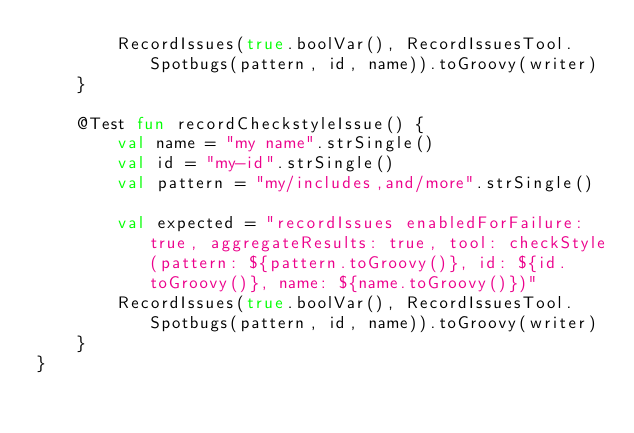Convert code to text. <code><loc_0><loc_0><loc_500><loc_500><_Kotlin_>        RecordIssues(true.boolVar(), RecordIssuesTool.Spotbugs(pattern, id, name)).toGroovy(writer)
    }

    @Test fun recordCheckstyleIssue() {
        val name = "my name".strSingle()
        val id = "my-id".strSingle()
        val pattern = "my/includes,and/more".strSingle()

        val expected = "recordIssues enabledForFailure: true, aggregateResults: true, tool: checkStyle(pattern: ${pattern.toGroovy()}, id: ${id.toGroovy()}, name: ${name.toGroovy()})"
        RecordIssues(true.boolVar(), RecordIssuesTool.Spotbugs(pattern, id, name)).toGroovy(writer)
    }
}
</code> 